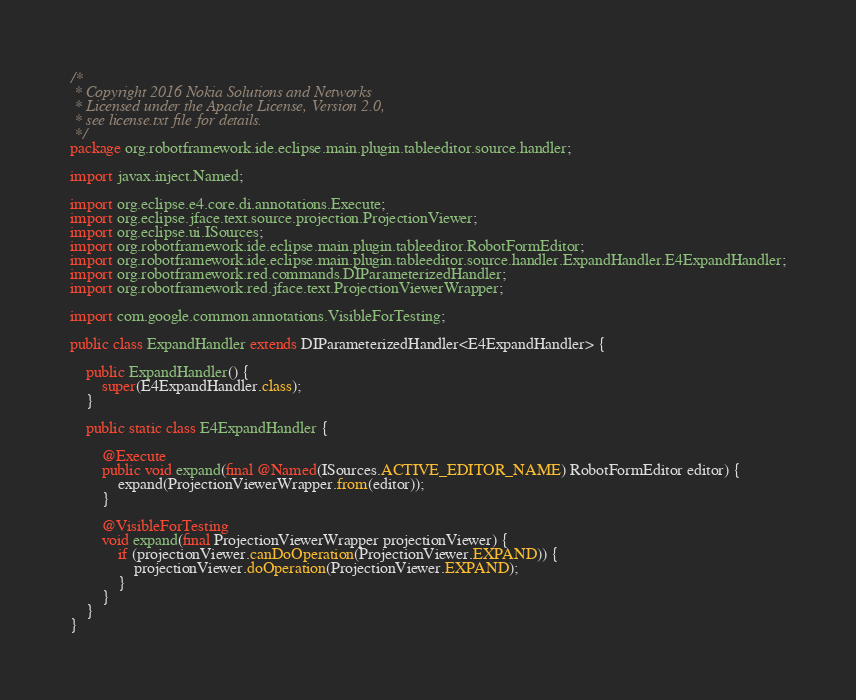Convert code to text. <code><loc_0><loc_0><loc_500><loc_500><_Java_>/*
 * Copyright 2016 Nokia Solutions and Networks
 * Licensed under the Apache License, Version 2.0,
 * see license.txt file for details.
 */
package org.robotframework.ide.eclipse.main.plugin.tableeditor.source.handler;

import javax.inject.Named;

import org.eclipse.e4.core.di.annotations.Execute;
import org.eclipse.jface.text.source.projection.ProjectionViewer;
import org.eclipse.ui.ISources;
import org.robotframework.ide.eclipse.main.plugin.tableeditor.RobotFormEditor;
import org.robotframework.ide.eclipse.main.plugin.tableeditor.source.handler.ExpandHandler.E4ExpandHandler;
import org.robotframework.red.commands.DIParameterizedHandler;
import org.robotframework.red.jface.text.ProjectionViewerWrapper;

import com.google.common.annotations.VisibleForTesting;

public class ExpandHandler extends DIParameterizedHandler<E4ExpandHandler> {

    public ExpandHandler() {
        super(E4ExpandHandler.class);
    }

    public static class E4ExpandHandler {

        @Execute
        public void expand(final @Named(ISources.ACTIVE_EDITOR_NAME) RobotFormEditor editor) {
            expand(ProjectionViewerWrapper.from(editor));
        }

        @VisibleForTesting
        void expand(final ProjectionViewerWrapper projectionViewer) {
            if (projectionViewer.canDoOperation(ProjectionViewer.EXPAND)) {
                projectionViewer.doOperation(ProjectionViewer.EXPAND);
            }
        }
    }
}
</code> 